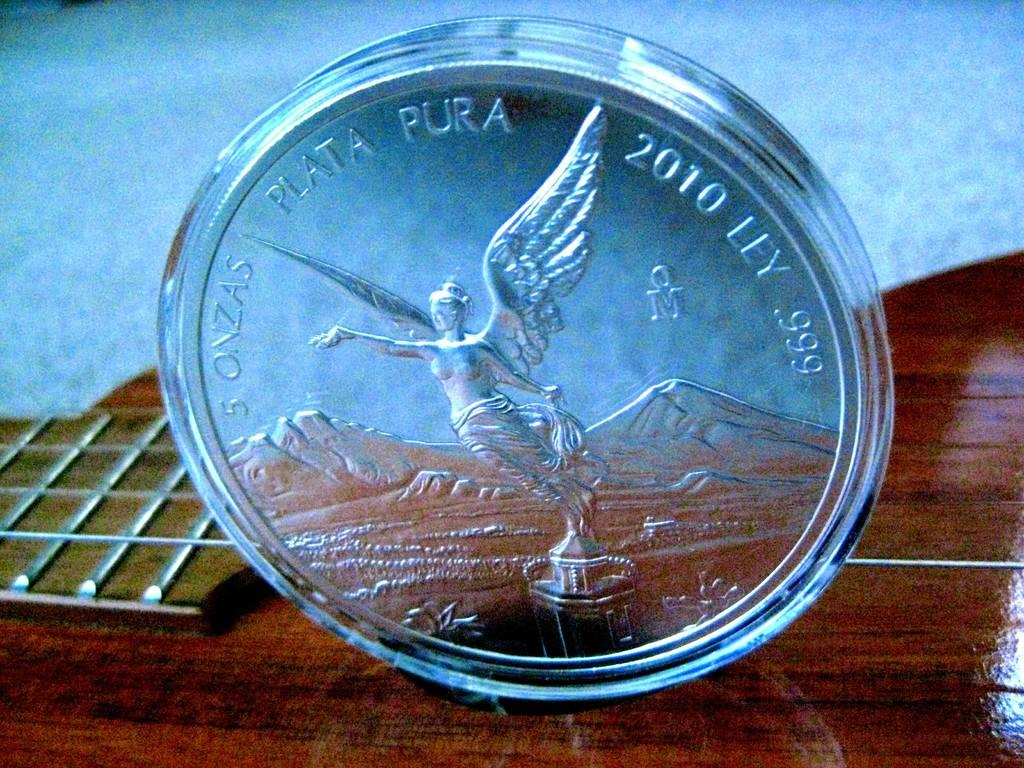Provide a one-sentence caption for the provided image. The writing on the silver coin indicates it is 5 ounces pure silver. 